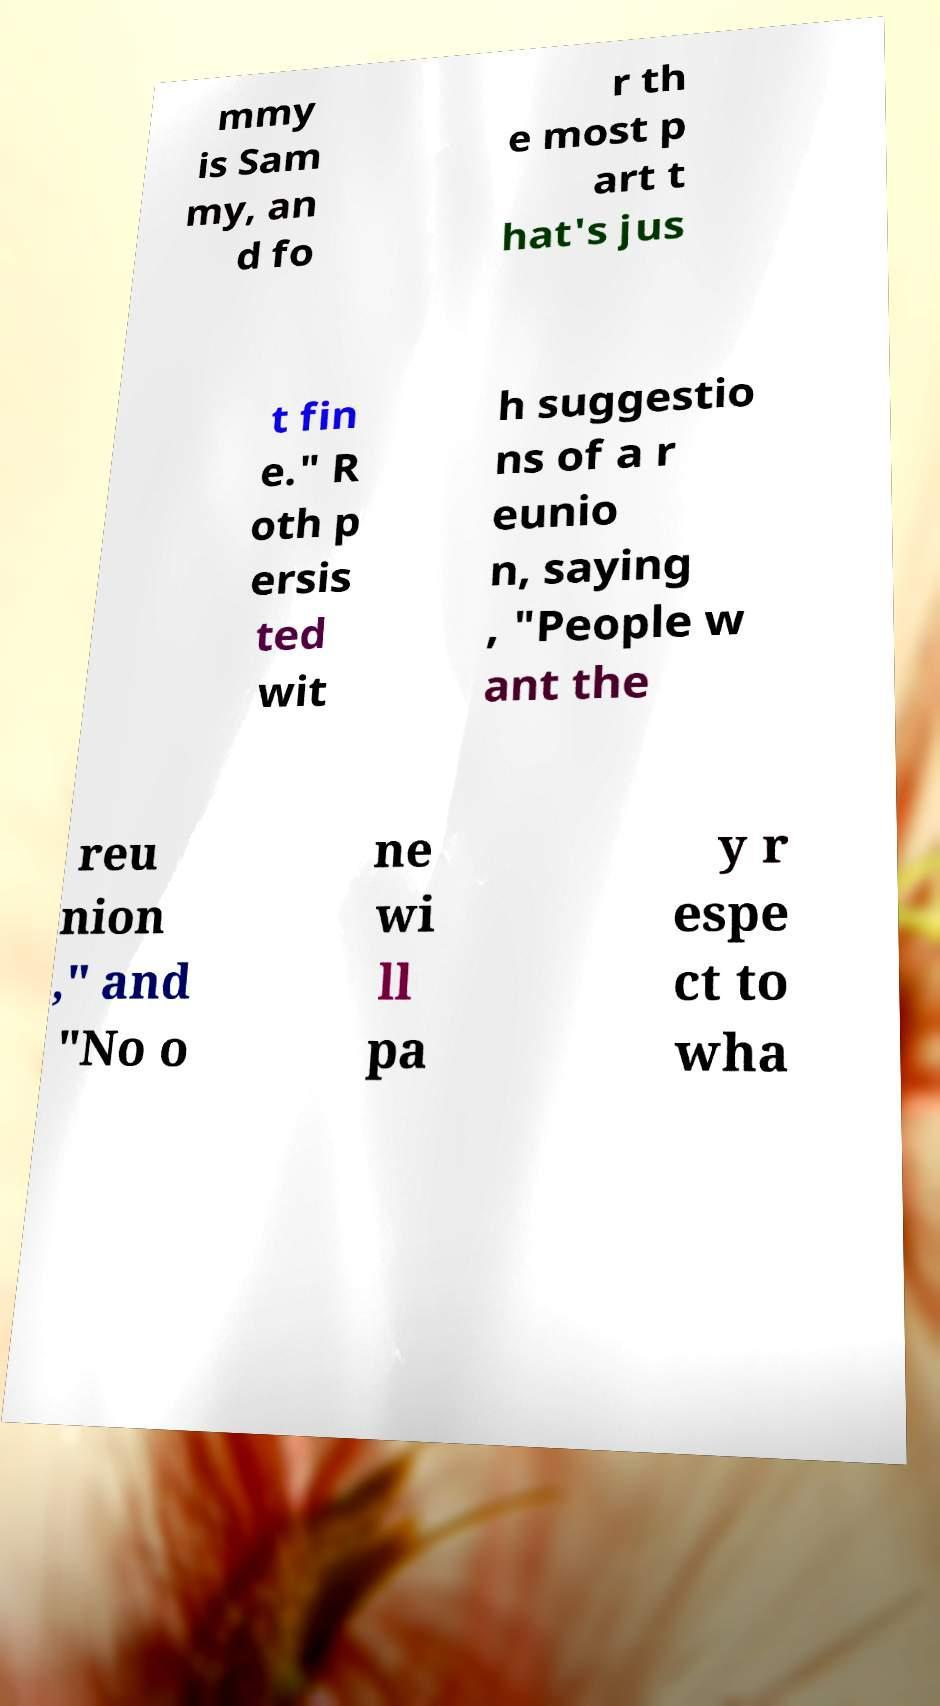For documentation purposes, I need the text within this image transcribed. Could you provide that? mmy is Sam my, an d fo r th e most p art t hat's jus t fin e." R oth p ersis ted wit h suggestio ns of a r eunio n, saying , "People w ant the reu nion ," and "No o ne wi ll pa y r espe ct to wha 